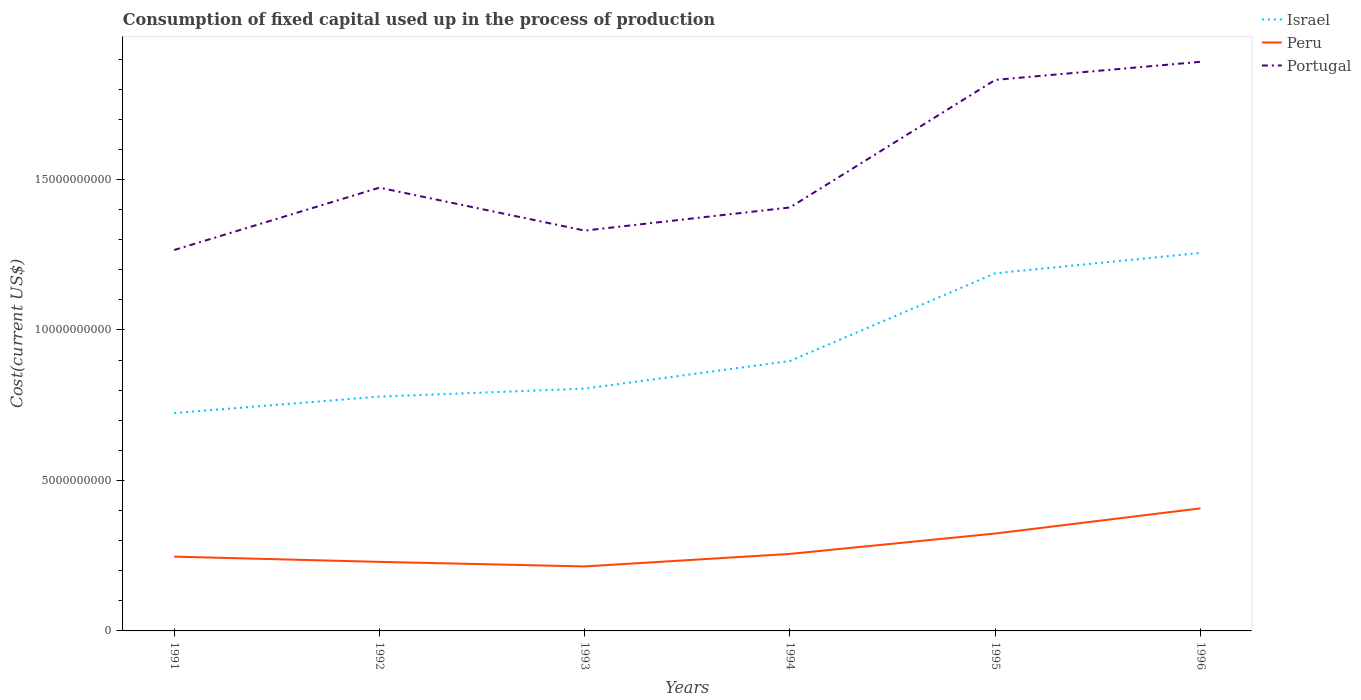How many different coloured lines are there?
Offer a very short reply. 3. Does the line corresponding to Portugal intersect with the line corresponding to Israel?
Offer a very short reply. No. Is the number of lines equal to the number of legend labels?
Your answer should be very brief. Yes. Across all years, what is the maximum amount consumed in the process of production in Portugal?
Offer a terse response. 1.27e+1. In which year was the amount consumed in the process of production in Portugal maximum?
Offer a very short reply. 1991. What is the total amount consumed in the process of production in Israel in the graph?
Provide a succinct answer. -2.65e+08. What is the difference between the highest and the second highest amount consumed in the process of production in Peru?
Give a very brief answer. 1.93e+09. What is the difference between the highest and the lowest amount consumed in the process of production in Israel?
Make the answer very short. 2. Is the amount consumed in the process of production in Peru strictly greater than the amount consumed in the process of production in Israel over the years?
Your response must be concise. Yes. How many lines are there?
Ensure brevity in your answer.  3. Where does the legend appear in the graph?
Your answer should be compact. Top right. How are the legend labels stacked?
Your response must be concise. Vertical. What is the title of the graph?
Offer a very short reply. Consumption of fixed capital used up in the process of production. Does "Togo" appear as one of the legend labels in the graph?
Make the answer very short. No. What is the label or title of the Y-axis?
Offer a very short reply. Cost(current US$). What is the Cost(current US$) of Israel in 1991?
Keep it short and to the point. 7.24e+09. What is the Cost(current US$) in Peru in 1991?
Provide a short and direct response. 2.47e+09. What is the Cost(current US$) in Portugal in 1991?
Make the answer very short. 1.27e+1. What is the Cost(current US$) of Israel in 1992?
Give a very brief answer. 7.78e+09. What is the Cost(current US$) in Peru in 1992?
Ensure brevity in your answer.  2.29e+09. What is the Cost(current US$) in Portugal in 1992?
Ensure brevity in your answer.  1.47e+1. What is the Cost(current US$) of Israel in 1993?
Your response must be concise. 8.05e+09. What is the Cost(current US$) of Peru in 1993?
Your response must be concise. 2.14e+09. What is the Cost(current US$) in Portugal in 1993?
Keep it short and to the point. 1.33e+1. What is the Cost(current US$) of Israel in 1994?
Offer a terse response. 8.97e+09. What is the Cost(current US$) in Peru in 1994?
Give a very brief answer. 2.56e+09. What is the Cost(current US$) in Portugal in 1994?
Provide a succinct answer. 1.41e+1. What is the Cost(current US$) of Israel in 1995?
Your response must be concise. 1.19e+1. What is the Cost(current US$) in Peru in 1995?
Offer a terse response. 3.24e+09. What is the Cost(current US$) in Portugal in 1995?
Offer a terse response. 1.83e+1. What is the Cost(current US$) in Israel in 1996?
Your answer should be compact. 1.26e+1. What is the Cost(current US$) of Peru in 1996?
Ensure brevity in your answer.  4.07e+09. What is the Cost(current US$) of Portugal in 1996?
Provide a short and direct response. 1.89e+1. Across all years, what is the maximum Cost(current US$) of Israel?
Your answer should be very brief. 1.26e+1. Across all years, what is the maximum Cost(current US$) of Peru?
Make the answer very short. 4.07e+09. Across all years, what is the maximum Cost(current US$) in Portugal?
Your response must be concise. 1.89e+1. Across all years, what is the minimum Cost(current US$) in Israel?
Provide a succinct answer. 7.24e+09. Across all years, what is the minimum Cost(current US$) of Peru?
Your response must be concise. 2.14e+09. Across all years, what is the minimum Cost(current US$) of Portugal?
Provide a short and direct response. 1.27e+1. What is the total Cost(current US$) in Israel in the graph?
Ensure brevity in your answer.  5.65e+1. What is the total Cost(current US$) of Peru in the graph?
Offer a very short reply. 1.68e+1. What is the total Cost(current US$) of Portugal in the graph?
Ensure brevity in your answer.  9.20e+1. What is the difference between the Cost(current US$) of Israel in 1991 and that in 1992?
Provide a succinct answer. -5.45e+08. What is the difference between the Cost(current US$) in Peru in 1991 and that in 1992?
Give a very brief answer. 1.75e+08. What is the difference between the Cost(current US$) in Portugal in 1991 and that in 1992?
Give a very brief answer. -2.07e+09. What is the difference between the Cost(current US$) of Israel in 1991 and that in 1993?
Make the answer very short. -8.10e+08. What is the difference between the Cost(current US$) of Peru in 1991 and that in 1993?
Keep it short and to the point. 3.26e+08. What is the difference between the Cost(current US$) in Portugal in 1991 and that in 1993?
Keep it short and to the point. -6.45e+08. What is the difference between the Cost(current US$) of Israel in 1991 and that in 1994?
Provide a short and direct response. -1.73e+09. What is the difference between the Cost(current US$) in Peru in 1991 and that in 1994?
Your answer should be very brief. -8.97e+07. What is the difference between the Cost(current US$) of Portugal in 1991 and that in 1994?
Ensure brevity in your answer.  -1.41e+09. What is the difference between the Cost(current US$) in Israel in 1991 and that in 1995?
Offer a terse response. -4.64e+09. What is the difference between the Cost(current US$) of Peru in 1991 and that in 1995?
Your answer should be very brief. -7.67e+08. What is the difference between the Cost(current US$) in Portugal in 1991 and that in 1995?
Keep it short and to the point. -5.65e+09. What is the difference between the Cost(current US$) of Israel in 1991 and that in 1996?
Offer a terse response. -5.32e+09. What is the difference between the Cost(current US$) in Peru in 1991 and that in 1996?
Make the answer very short. -1.60e+09. What is the difference between the Cost(current US$) in Portugal in 1991 and that in 1996?
Your response must be concise. -6.25e+09. What is the difference between the Cost(current US$) of Israel in 1992 and that in 1993?
Keep it short and to the point. -2.65e+08. What is the difference between the Cost(current US$) in Peru in 1992 and that in 1993?
Offer a very short reply. 1.51e+08. What is the difference between the Cost(current US$) of Portugal in 1992 and that in 1993?
Make the answer very short. 1.43e+09. What is the difference between the Cost(current US$) in Israel in 1992 and that in 1994?
Ensure brevity in your answer.  -1.18e+09. What is the difference between the Cost(current US$) in Peru in 1992 and that in 1994?
Provide a short and direct response. -2.65e+08. What is the difference between the Cost(current US$) of Portugal in 1992 and that in 1994?
Give a very brief answer. 6.58e+08. What is the difference between the Cost(current US$) of Israel in 1992 and that in 1995?
Your answer should be compact. -4.10e+09. What is the difference between the Cost(current US$) in Peru in 1992 and that in 1995?
Offer a terse response. -9.42e+08. What is the difference between the Cost(current US$) in Portugal in 1992 and that in 1995?
Make the answer very short. -3.58e+09. What is the difference between the Cost(current US$) of Israel in 1992 and that in 1996?
Your response must be concise. -4.77e+09. What is the difference between the Cost(current US$) in Peru in 1992 and that in 1996?
Your answer should be very brief. -1.78e+09. What is the difference between the Cost(current US$) of Portugal in 1992 and that in 1996?
Provide a short and direct response. -4.18e+09. What is the difference between the Cost(current US$) in Israel in 1993 and that in 1994?
Provide a short and direct response. -9.18e+08. What is the difference between the Cost(current US$) in Peru in 1993 and that in 1994?
Give a very brief answer. -4.16e+08. What is the difference between the Cost(current US$) of Portugal in 1993 and that in 1994?
Provide a short and direct response. -7.69e+08. What is the difference between the Cost(current US$) of Israel in 1993 and that in 1995?
Ensure brevity in your answer.  -3.83e+09. What is the difference between the Cost(current US$) in Peru in 1993 and that in 1995?
Your answer should be compact. -1.09e+09. What is the difference between the Cost(current US$) of Portugal in 1993 and that in 1995?
Offer a terse response. -5.01e+09. What is the difference between the Cost(current US$) in Israel in 1993 and that in 1996?
Provide a short and direct response. -4.51e+09. What is the difference between the Cost(current US$) in Peru in 1993 and that in 1996?
Make the answer very short. -1.93e+09. What is the difference between the Cost(current US$) in Portugal in 1993 and that in 1996?
Make the answer very short. -5.61e+09. What is the difference between the Cost(current US$) in Israel in 1994 and that in 1995?
Offer a very short reply. -2.91e+09. What is the difference between the Cost(current US$) in Peru in 1994 and that in 1995?
Offer a terse response. -6.77e+08. What is the difference between the Cost(current US$) of Portugal in 1994 and that in 1995?
Your response must be concise. -4.24e+09. What is the difference between the Cost(current US$) of Israel in 1994 and that in 1996?
Offer a very short reply. -3.59e+09. What is the difference between the Cost(current US$) in Peru in 1994 and that in 1996?
Keep it short and to the point. -1.51e+09. What is the difference between the Cost(current US$) in Portugal in 1994 and that in 1996?
Your answer should be compact. -4.84e+09. What is the difference between the Cost(current US$) in Israel in 1995 and that in 1996?
Your answer should be very brief. -6.74e+08. What is the difference between the Cost(current US$) in Peru in 1995 and that in 1996?
Your response must be concise. -8.36e+08. What is the difference between the Cost(current US$) of Portugal in 1995 and that in 1996?
Your answer should be very brief. -6.00e+08. What is the difference between the Cost(current US$) in Israel in 1991 and the Cost(current US$) in Peru in 1992?
Keep it short and to the point. 4.95e+09. What is the difference between the Cost(current US$) in Israel in 1991 and the Cost(current US$) in Portugal in 1992?
Your response must be concise. -7.49e+09. What is the difference between the Cost(current US$) in Peru in 1991 and the Cost(current US$) in Portugal in 1992?
Give a very brief answer. -1.23e+1. What is the difference between the Cost(current US$) in Israel in 1991 and the Cost(current US$) in Peru in 1993?
Keep it short and to the point. 5.10e+09. What is the difference between the Cost(current US$) of Israel in 1991 and the Cost(current US$) of Portugal in 1993?
Your response must be concise. -6.06e+09. What is the difference between the Cost(current US$) in Peru in 1991 and the Cost(current US$) in Portugal in 1993?
Make the answer very short. -1.08e+1. What is the difference between the Cost(current US$) of Israel in 1991 and the Cost(current US$) of Peru in 1994?
Keep it short and to the point. 4.68e+09. What is the difference between the Cost(current US$) in Israel in 1991 and the Cost(current US$) in Portugal in 1994?
Give a very brief answer. -6.83e+09. What is the difference between the Cost(current US$) of Peru in 1991 and the Cost(current US$) of Portugal in 1994?
Your answer should be compact. -1.16e+1. What is the difference between the Cost(current US$) of Israel in 1991 and the Cost(current US$) of Peru in 1995?
Your response must be concise. 4.00e+09. What is the difference between the Cost(current US$) in Israel in 1991 and the Cost(current US$) in Portugal in 1995?
Give a very brief answer. -1.11e+1. What is the difference between the Cost(current US$) of Peru in 1991 and the Cost(current US$) of Portugal in 1995?
Make the answer very short. -1.58e+1. What is the difference between the Cost(current US$) of Israel in 1991 and the Cost(current US$) of Peru in 1996?
Your answer should be compact. 3.17e+09. What is the difference between the Cost(current US$) of Israel in 1991 and the Cost(current US$) of Portugal in 1996?
Your answer should be compact. -1.17e+1. What is the difference between the Cost(current US$) in Peru in 1991 and the Cost(current US$) in Portugal in 1996?
Make the answer very short. -1.64e+1. What is the difference between the Cost(current US$) in Israel in 1992 and the Cost(current US$) in Peru in 1993?
Ensure brevity in your answer.  5.64e+09. What is the difference between the Cost(current US$) of Israel in 1992 and the Cost(current US$) of Portugal in 1993?
Your response must be concise. -5.52e+09. What is the difference between the Cost(current US$) in Peru in 1992 and the Cost(current US$) in Portugal in 1993?
Your response must be concise. -1.10e+1. What is the difference between the Cost(current US$) of Israel in 1992 and the Cost(current US$) of Peru in 1994?
Give a very brief answer. 5.23e+09. What is the difference between the Cost(current US$) in Israel in 1992 and the Cost(current US$) in Portugal in 1994?
Offer a terse response. -6.28e+09. What is the difference between the Cost(current US$) in Peru in 1992 and the Cost(current US$) in Portugal in 1994?
Your answer should be compact. -1.18e+1. What is the difference between the Cost(current US$) of Israel in 1992 and the Cost(current US$) of Peru in 1995?
Your response must be concise. 4.55e+09. What is the difference between the Cost(current US$) in Israel in 1992 and the Cost(current US$) in Portugal in 1995?
Give a very brief answer. -1.05e+1. What is the difference between the Cost(current US$) in Peru in 1992 and the Cost(current US$) in Portugal in 1995?
Keep it short and to the point. -1.60e+1. What is the difference between the Cost(current US$) in Israel in 1992 and the Cost(current US$) in Peru in 1996?
Your answer should be compact. 3.71e+09. What is the difference between the Cost(current US$) in Israel in 1992 and the Cost(current US$) in Portugal in 1996?
Your answer should be compact. -1.11e+1. What is the difference between the Cost(current US$) in Peru in 1992 and the Cost(current US$) in Portugal in 1996?
Make the answer very short. -1.66e+1. What is the difference between the Cost(current US$) in Israel in 1993 and the Cost(current US$) in Peru in 1994?
Provide a short and direct response. 5.49e+09. What is the difference between the Cost(current US$) of Israel in 1993 and the Cost(current US$) of Portugal in 1994?
Your answer should be compact. -6.02e+09. What is the difference between the Cost(current US$) in Peru in 1993 and the Cost(current US$) in Portugal in 1994?
Provide a short and direct response. -1.19e+1. What is the difference between the Cost(current US$) in Israel in 1993 and the Cost(current US$) in Peru in 1995?
Provide a short and direct response. 4.81e+09. What is the difference between the Cost(current US$) of Israel in 1993 and the Cost(current US$) of Portugal in 1995?
Your answer should be very brief. -1.03e+1. What is the difference between the Cost(current US$) of Peru in 1993 and the Cost(current US$) of Portugal in 1995?
Make the answer very short. -1.62e+1. What is the difference between the Cost(current US$) in Israel in 1993 and the Cost(current US$) in Peru in 1996?
Provide a short and direct response. 3.98e+09. What is the difference between the Cost(current US$) of Israel in 1993 and the Cost(current US$) of Portugal in 1996?
Give a very brief answer. -1.09e+1. What is the difference between the Cost(current US$) in Peru in 1993 and the Cost(current US$) in Portugal in 1996?
Make the answer very short. -1.68e+1. What is the difference between the Cost(current US$) of Israel in 1994 and the Cost(current US$) of Peru in 1995?
Give a very brief answer. 5.73e+09. What is the difference between the Cost(current US$) in Israel in 1994 and the Cost(current US$) in Portugal in 1995?
Your response must be concise. -9.34e+09. What is the difference between the Cost(current US$) of Peru in 1994 and the Cost(current US$) of Portugal in 1995?
Your answer should be very brief. -1.57e+1. What is the difference between the Cost(current US$) in Israel in 1994 and the Cost(current US$) in Peru in 1996?
Offer a terse response. 4.90e+09. What is the difference between the Cost(current US$) of Israel in 1994 and the Cost(current US$) of Portugal in 1996?
Your response must be concise. -9.94e+09. What is the difference between the Cost(current US$) in Peru in 1994 and the Cost(current US$) in Portugal in 1996?
Offer a very short reply. -1.63e+1. What is the difference between the Cost(current US$) of Israel in 1995 and the Cost(current US$) of Peru in 1996?
Your answer should be very brief. 7.81e+09. What is the difference between the Cost(current US$) of Israel in 1995 and the Cost(current US$) of Portugal in 1996?
Provide a succinct answer. -7.03e+09. What is the difference between the Cost(current US$) of Peru in 1995 and the Cost(current US$) of Portugal in 1996?
Your answer should be very brief. -1.57e+1. What is the average Cost(current US$) in Israel per year?
Offer a very short reply. 9.41e+09. What is the average Cost(current US$) of Peru per year?
Offer a terse response. 2.80e+09. What is the average Cost(current US$) in Portugal per year?
Provide a succinct answer. 1.53e+1. In the year 1991, what is the difference between the Cost(current US$) in Israel and Cost(current US$) in Peru?
Your answer should be compact. 4.77e+09. In the year 1991, what is the difference between the Cost(current US$) in Israel and Cost(current US$) in Portugal?
Ensure brevity in your answer.  -5.42e+09. In the year 1991, what is the difference between the Cost(current US$) of Peru and Cost(current US$) of Portugal?
Provide a succinct answer. -1.02e+1. In the year 1992, what is the difference between the Cost(current US$) of Israel and Cost(current US$) of Peru?
Your answer should be compact. 5.49e+09. In the year 1992, what is the difference between the Cost(current US$) of Israel and Cost(current US$) of Portugal?
Your response must be concise. -6.94e+09. In the year 1992, what is the difference between the Cost(current US$) of Peru and Cost(current US$) of Portugal?
Keep it short and to the point. -1.24e+1. In the year 1993, what is the difference between the Cost(current US$) of Israel and Cost(current US$) of Peru?
Ensure brevity in your answer.  5.91e+09. In the year 1993, what is the difference between the Cost(current US$) of Israel and Cost(current US$) of Portugal?
Offer a very short reply. -5.25e+09. In the year 1993, what is the difference between the Cost(current US$) in Peru and Cost(current US$) in Portugal?
Make the answer very short. -1.12e+1. In the year 1994, what is the difference between the Cost(current US$) in Israel and Cost(current US$) in Peru?
Ensure brevity in your answer.  6.41e+09. In the year 1994, what is the difference between the Cost(current US$) of Israel and Cost(current US$) of Portugal?
Your answer should be very brief. -5.10e+09. In the year 1994, what is the difference between the Cost(current US$) in Peru and Cost(current US$) in Portugal?
Your answer should be very brief. -1.15e+1. In the year 1995, what is the difference between the Cost(current US$) of Israel and Cost(current US$) of Peru?
Ensure brevity in your answer.  8.65e+09. In the year 1995, what is the difference between the Cost(current US$) in Israel and Cost(current US$) in Portugal?
Your response must be concise. -6.43e+09. In the year 1995, what is the difference between the Cost(current US$) of Peru and Cost(current US$) of Portugal?
Ensure brevity in your answer.  -1.51e+1. In the year 1996, what is the difference between the Cost(current US$) in Israel and Cost(current US$) in Peru?
Your answer should be compact. 8.48e+09. In the year 1996, what is the difference between the Cost(current US$) of Israel and Cost(current US$) of Portugal?
Ensure brevity in your answer.  -6.35e+09. In the year 1996, what is the difference between the Cost(current US$) of Peru and Cost(current US$) of Portugal?
Keep it short and to the point. -1.48e+1. What is the ratio of the Cost(current US$) of Israel in 1991 to that in 1992?
Your answer should be compact. 0.93. What is the ratio of the Cost(current US$) of Peru in 1991 to that in 1992?
Offer a very short reply. 1.08. What is the ratio of the Cost(current US$) of Portugal in 1991 to that in 1992?
Give a very brief answer. 0.86. What is the ratio of the Cost(current US$) in Israel in 1991 to that in 1993?
Offer a terse response. 0.9. What is the ratio of the Cost(current US$) of Peru in 1991 to that in 1993?
Ensure brevity in your answer.  1.15. What is the ratio of the Cost(current US$) in Portugal in 1991 to that in 1993?
Your answer should be compact. 0.95. What is the ratio of the Cost(current US$) in Israel in 1991 to that in 1994?
Ensure brevity in your answer.  0.81. What is the ratio of the Cost(current US$) of Portugal in 1991 to that in 1994?
Give a very brief answer. 0.9. What is the ratio of the Cost(current US$) of Israel in 1991 to that in 1995?
Give a very brief answer. 0.61. What is the ratio of the Cost(current US$) in Peru in 1991 to that in 1995?
Ensure brevity in your answer.  0.76. What is the ratio of the Cost(current US$) of Portugal in 1991 to that in 1995?
Your response must be concise. 0.69. What is the ratio of the Cost(current US$) in Israel in 1991 to that in 1996?
Keep it short and to the point. 0.58. What is the ratio of the Cost(current US$) in Peru in 1991 to that in 1996?
Offer a very short reply. 0.61. What is the ratio of the Cost(current US$) in Portugal in 1991 to that in 1996?
Provide a succinct answer. 0.67. What is the ratio of the Cost(current US$) in Israel in 1992 to that in 1993?
Your answer should be very brief. 0.97. What is the ratio of the Cost(current US$) in Peru in 1992 to that in 1993?
Provide a short and direct response. 1.07. What is the ratio of the Cost(current US$) in Portugal in 1992 to that in 1993?
Your response must be concise. 1.11. What is the ratio of the Cost(current US$) of Israel in 1992 to that in 1994?
Keep it short and to the point. 0.87. What is the ratio of the Cost(current US$) of Peru in 1992 to that in 1994?
Offer a very short reply. 0.9. What is the ratio of the Cost(current US$) in Portugal in 1992 to that in 1994?
Offer a terse response. 1.05. What is the ratio of the Cost(current US$) of Israel in 1992 to that in 1995?
Your response must be concise. 0.66. What is the ratio of the Cost(current US$) in Peru in 1992 to that in 1995?
Give a very brief answer. 0.71. What is the ratio of the Cost(current US$) of Portugal in 1992 to that in 1995?
Your response must be concise. 0.8. What is the ratio of the Cost(current US$) in Israel in 1992 to that in 1996?
Provide a succinct answer. 0.62. What is the ratio of the Cost(current US$) of Peru in 1992 to that in 1996?
Provide a succinct answer. 0.56. What is the ratio of the Cost(current US$) in Portugal in 1992 to that in 1996?
Provide a succinct answer. 0.78. What is the ratio of the Cost(current US$) of Israel in 1993 to that in 1994?
Your answer should be very brief. 0.9. What is the ratio of the Cost(current US$) of Peru in 1993 to that in 1994?
Provide a short and direct response. 0.84. What is the ratio of the Cost(current US$) in Portugal in 1993 to that in 1994?
Give a very brief answer. 0.95. What is the ratio of the Cost(current US$) in Israel in 1993 to that in 1995?
Ensure brevity in your answer.  0.68. What is the ratio of the Cost(current US$) of Peru in 1993 to that in 1995?
Offer a terse response. 0.66. What is the ratio of the Cost(current US$) of Portugal in 1993 to that in 1995?
Your response must be concise. 0.73. What is the ratio of the Cost(current US$) of Israel in 1993 to that in 1996?
Keep it short and to the point. 0.64. What is the ratio of the Cost(current US$) of Peru in 1993 to that in 1996?
Ensure brevity in your answer.  0.53. What is the ratio of the Cost(current US$) in Portugal in 1993 to that in 1996?
Your response must be concise. 0.7. What is the ratio of the Cost(current US$) of Israel in 1994 to that in 1995?
Make the answer very short. 0.75. What is the ratio of the Cost(current US$) in Peru in 1994 to that in 1995?
Your answer should be compact. 0.79. What is the ratio of the Cost(current US$) of Portugal in 1994 to that in 1995?
Your answer should be very brief. 0.77. What is the ratio of the Cost(current US$) in Israel in 1994 to that in 1996?
Your answer should be compact. 0.71. What is the ratio of the Cost(current US$) of Peru in 1994 to that in 1996?
Give a very brief answer. 0.63. What is the ratio of the Cost(current US$) of Portugal in 1994 to that in 1996?
Make the answer very short. 0.74. What is the ratio of the Cost(current US$) of Israel in 1995 to that in 1996?
Your answer should be compact. 0.95. What is the ratio of the Cost(current US$) in Peru in 1995 to that in 1996?
Provide a short and direct response. 0.79. What is the ratio of the Cost(current US$) in Portugal in 1995 to that in 1996?
Offer a terse response. 0.97. What is the difference between the highest and the second highest Cost(current US$) in Israel?
Your answer should be compact. 6.74e+08. What is the difference between the highest and the second highest Cost(current US$) in Peru?
Offer a terse response. 8.36e+08. What is the difference between the highest and the second highest Cost(current US$) in Portugal?
Your answer should be compact. 6.00e+08. What is the difference between the highest and the lowest Cost(current US$) in Israel?
Your answer should be very brief. 5.32e+09. What is the difference between the highest and the lowest Cost(current US$) in Peru?
Offer a very short reply. 1.93e+09. What is the difference between the highest and the lowest Cost(current US$) in Portugal?
Provide a short and direct response. 6.25e+09. 